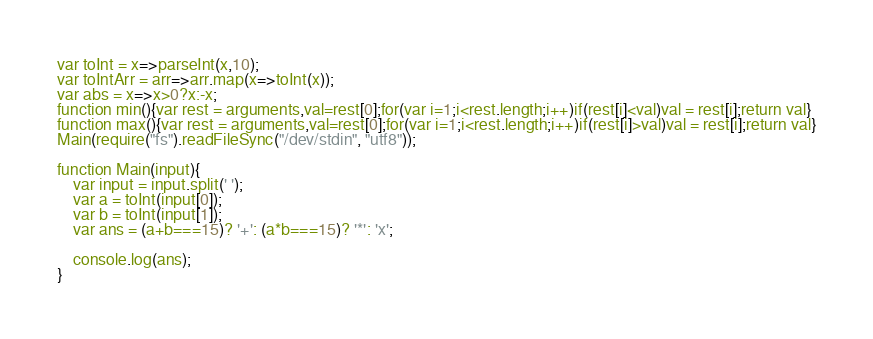<code> <loc_0><loc_0><loc_500><loc_500><_JavaScript_>var toInt = x=>parseInt(x,10);
var toIntArr = arr=>arr.map(x=>toInt(x));
var abs = x=>x>0?x:-x;
function min(){var rest = arguments,val=rest[0];for(var i=1;i<rest.length;i++)if(rest[i]<val)val = rest[i];return val}
function max(){var rest = arguments,val=rest[0];for(var i=1;i<rest.length;i++)if(rest[i]>val)val = rest[i];return val}
Main(require("fs").readFileSync("/dev/stdin", "utf8"));
 
function Main(input){
	var input = input.split(' ');
	var a = toInt(input[0]);
	var b = toInt(input[1]);
	var ans = (a+b===15)? '+': (a*b===15)? '*': 'x';

	console.log(ans);
}</code> 